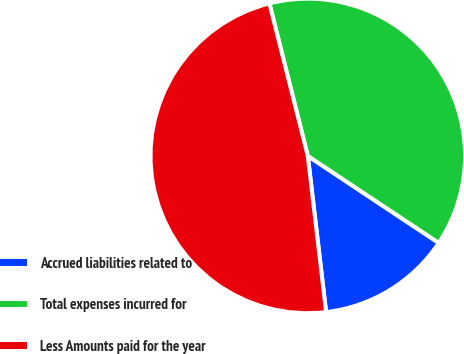Convert chart. <chart><loc_0><loc_0><loc_500><loc_500><pie_chart><fcel>Accrued liabilities related to<fcel>Total expenses incurred for<fcel>Less Amounts paid for the year<nl><fcel>13.81%<fcel>38.26%<fcel>47.93%<nl></chart> 